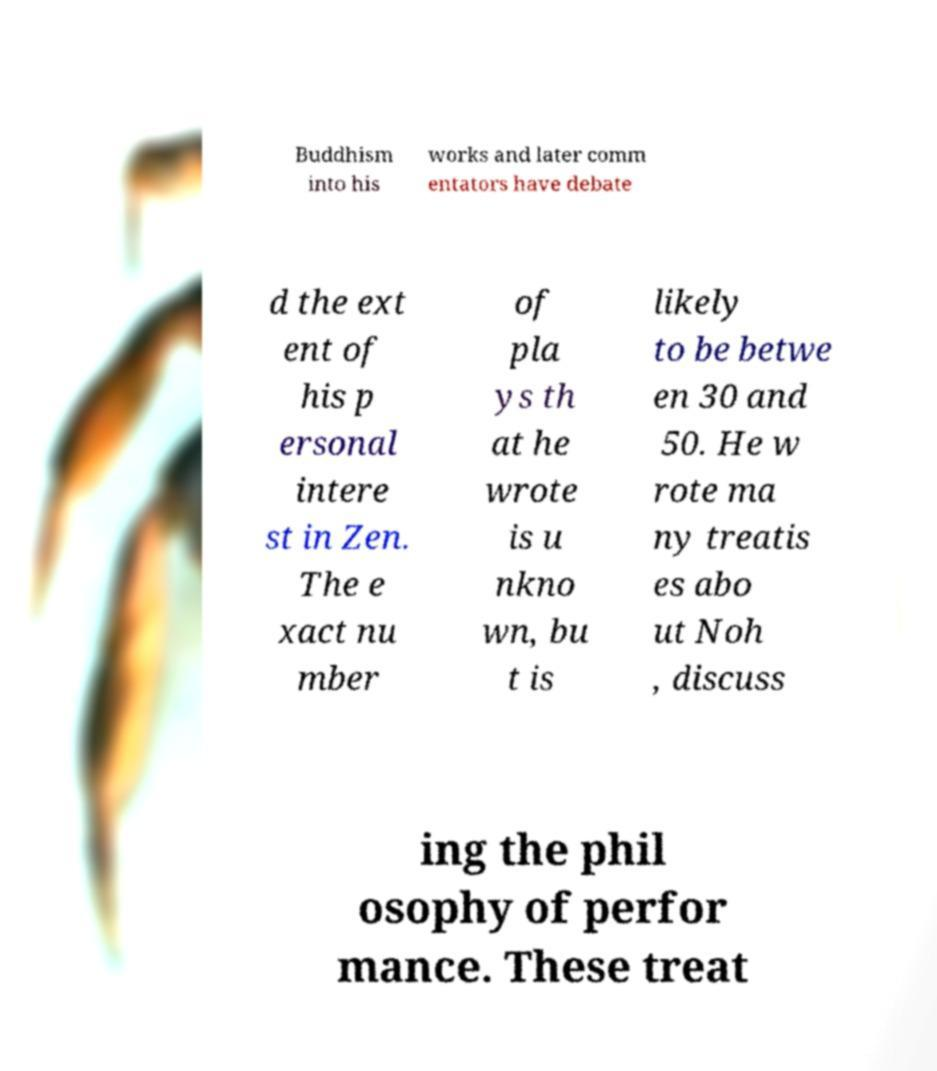I need the written content from this picture converted into text. Can you do that? Buddhism into his works and later comm entators have debate d the ext ent of his p ersonal intere st in Zen. The e xact nu mber of pla ys th at he wrote is u nkno wn, bu t is likely to be betwe en 30 and 50. He w rote ma ny treatis es abo ut Noh , discuss ing the phil osophy of perfor mance. These treat 